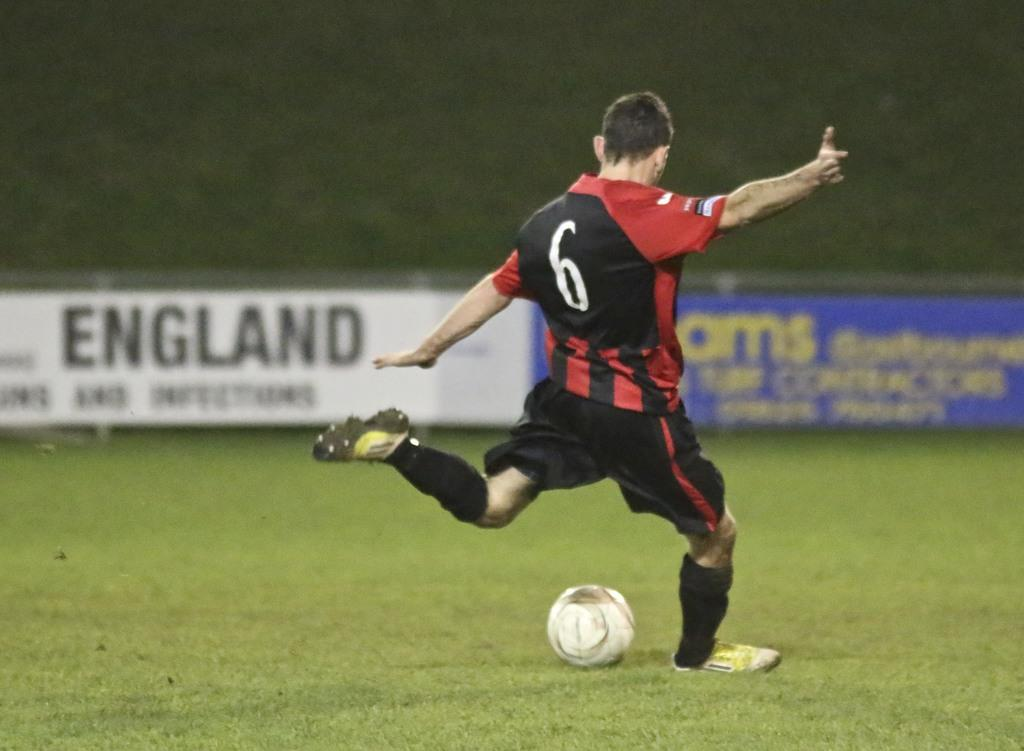<image>
Present a compact description of the photo's key features. A man with a number 6 on his back kicking a football 